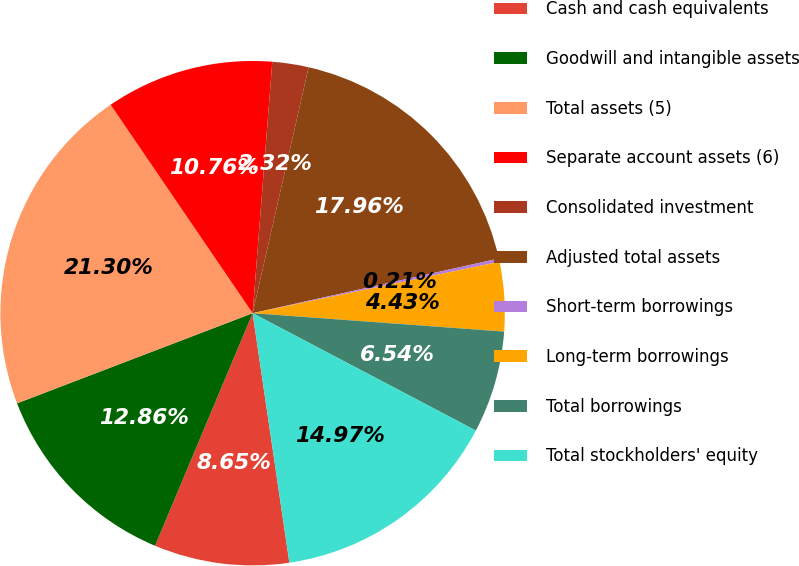Convert chart. <chart><loc_0><loc_0><loc_500><loc_500><pie_chart><fcel>Cash and cash equivalents<fcel>Goodwill and intangible assets<fcel>Total assets (5)<fcel>Separate account assets (6)<fcel>Consolidated investment<fcel>Adjusted total assets<fcel>Short-term borrowings<fcel>Long-term borrowings<fcel>Total borrowings<fcel>Total stockholders' equity<nl><fcel>8.65%<fcel>12.86%<fcel>21.3%<fcel>10.76%<fcel>2.32%<fcel>17.96%<fcel>0.21%<fcel>4.43%<fcel>6.54%<fcel>14.97%<nl></chart> 